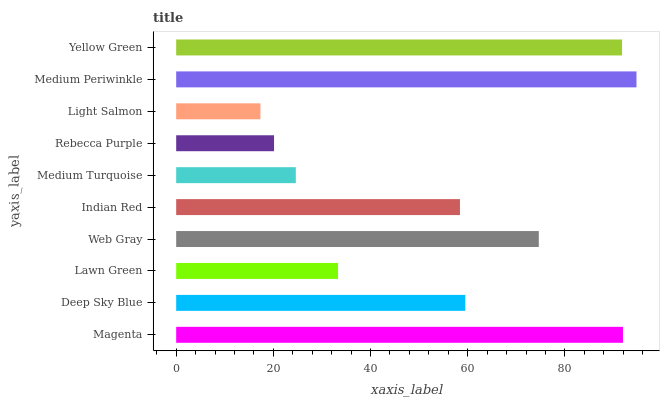Is Light Salmon the minimum?
Answer yes or no. Yes. Is Medium Periwinkle the maximum?
Answer yes or no. Yes. Is Deep Sky Blue the minimum?
Answer yes or no. No. Is Deep Sky Blue the maximum?
Answer yes or no. No. Is Magenta greater than Deep Sky Blue?
Answer yes or no. Yes. Is Deep Sky Blue less than Magenta?
Answer yes or no. Yes. Is Deep Sky Blue greater than Magenta?
Answer yes or no. No. Is Magenta less than Deep Sky Blue?
Answer yes or no. No. Is Deep Sky Blue the high median?
Answer yes or no. Yes. Is Indian Red the low median?
Answer yes or no. Yes. Is Light Salmon the high median?
Answer yes or no. No. Is Web Gray the low median?
Answer yes or no. No. 